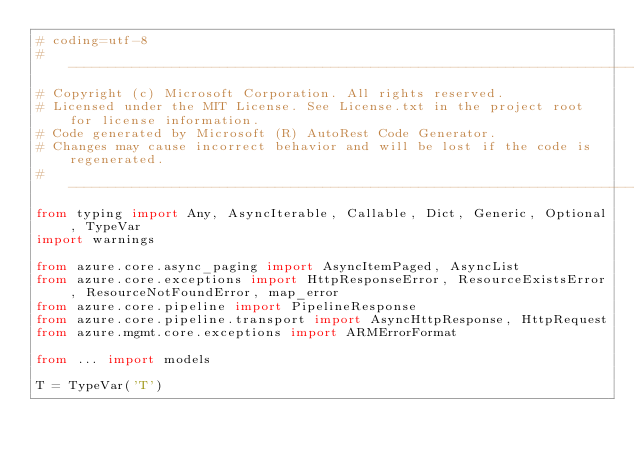Convert code to text. <code><loc_0><loc_0><loc_500><loc_500><_Python_># coding=utf-8
# --------------------------------------------------------------------------
# Copyright (c) Microsoft Corporation. All rights reserved.
# Licensed under the MIT License. See License.txt in the project root for license information.
# Code generated by Microsoft (R) AutoRest Code Generator.
# Changes may cause incorrect behavior and will be lost if the code is regenerated.
# --------------------------------------------------------------------------
from typing import Any, AsyncIterable, Callable, Dict, Generic, Optional, TypeVar
import warnings

from azure.core.async_paging import AsyncItemPaged, AsyncList
from azure.core.exceptions import HttpResponseError, ResourceExistsError, ResourceNotFoundError, map_error
from azure.core.pipeline import PipelineResponse
from azure.core.pipeline.transport import AsyncHttpResponse, HttpRequest
from azure.mgmt.core.exceptions import ARMErrorFormat

from ... import models

T = TypeVar('T')</code> 